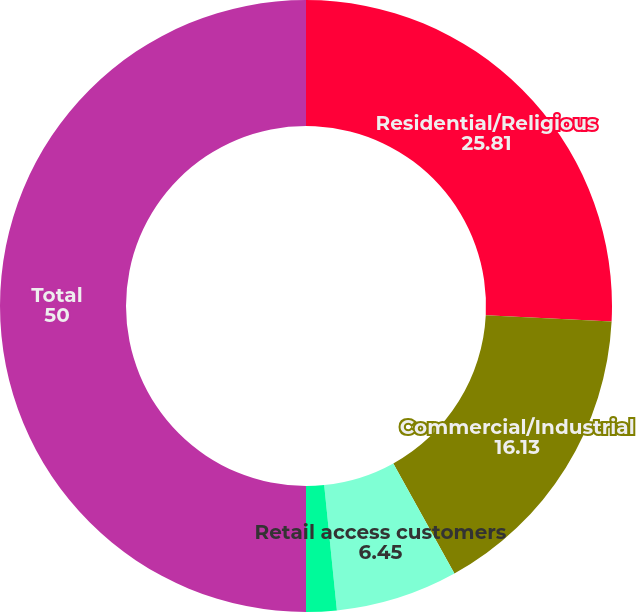Convert chart to OTSL. <chart><loc_0><loc_0><loc_500><loc_500><pie_chart><fcel>Residential/Religious<fcel>Commercial/Industrial<fcel>Retail access customers<fcel>Public authorities<fcel>Total<nl><fcel>25.81%<fcel>16.13%<fcel>6.45%<fcel>1.61%<fcel>50.0%<nl></chart> 